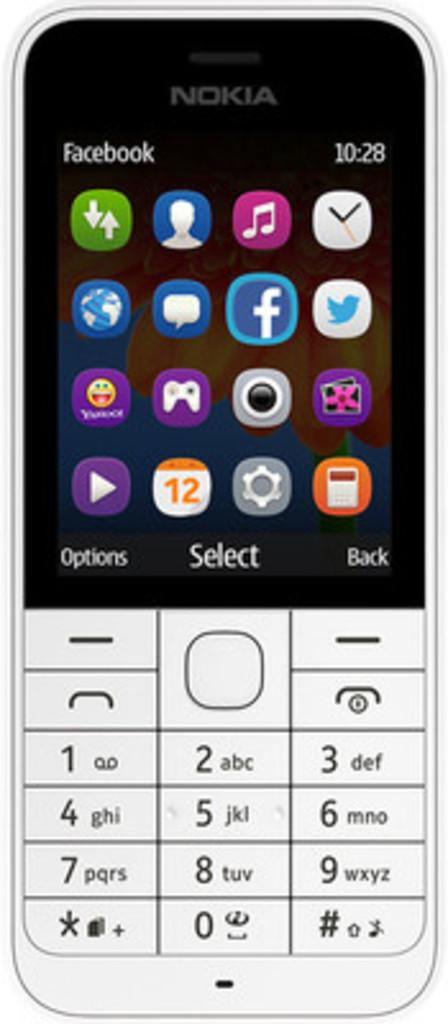<image>
Summarize the visual content of the image. A close up of a phone that has the time 10:28 on the top right. 